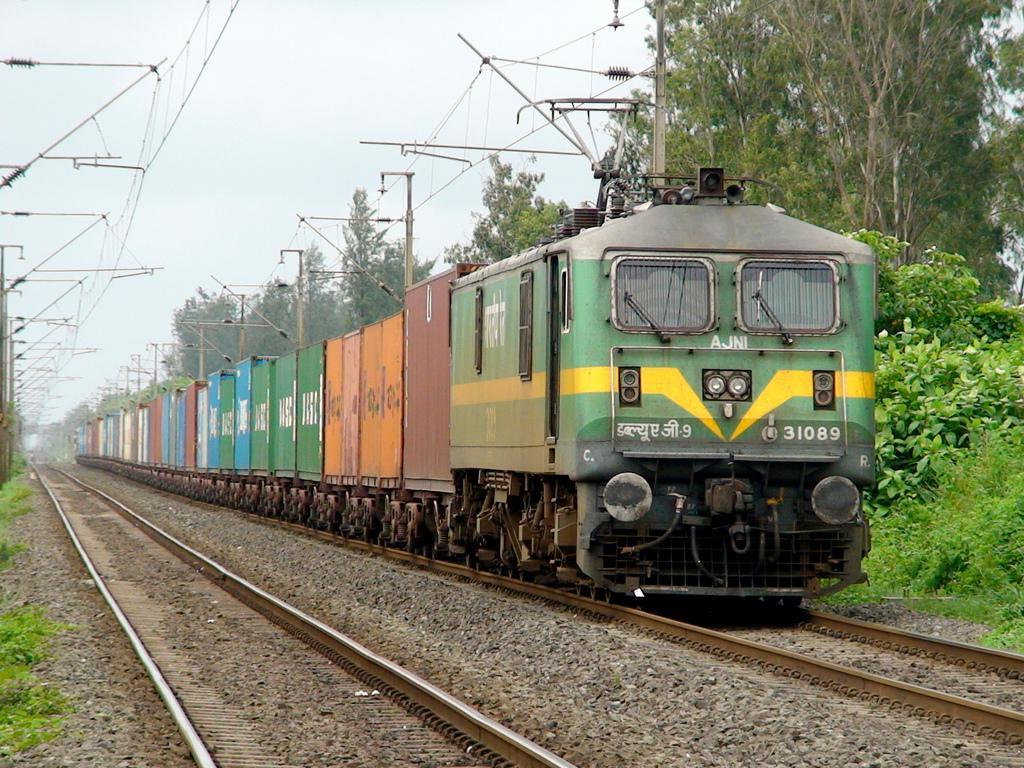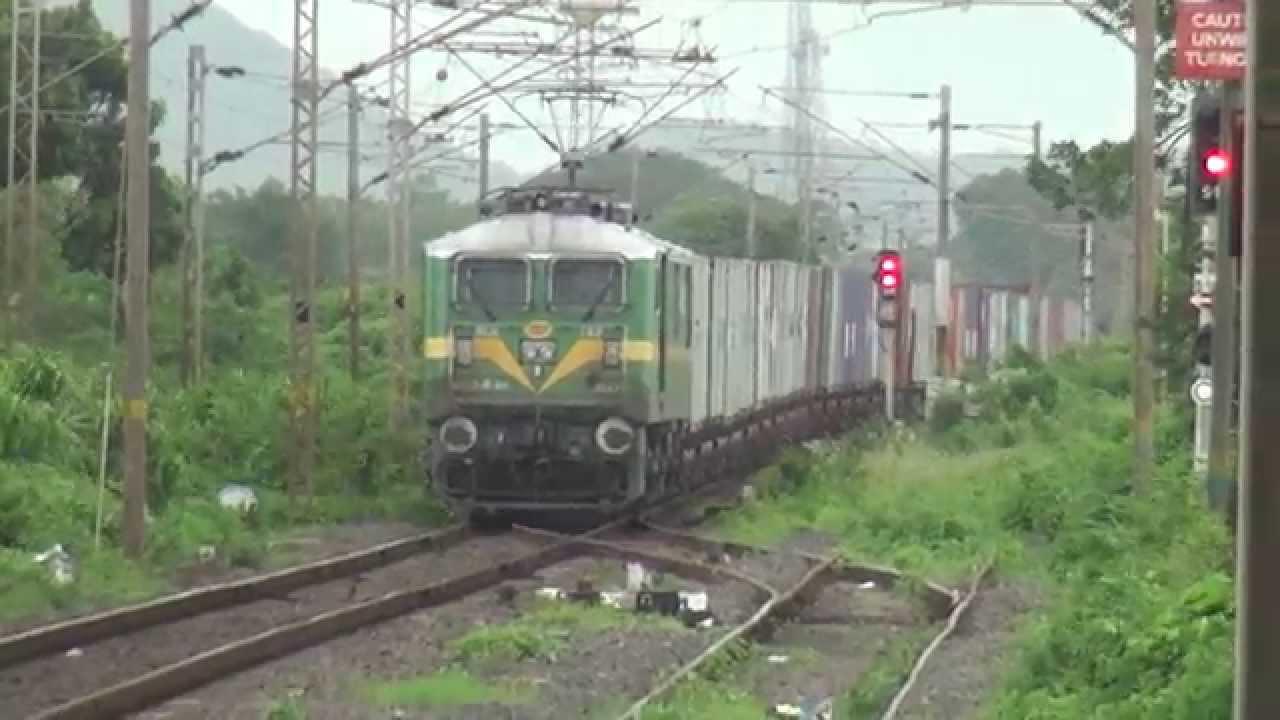The first image is the image on the left, the second image is the image on the right. Considering the images on both sides, is "The train in the image on the left is moving towards the left." valid? Answer yes or no. No. 